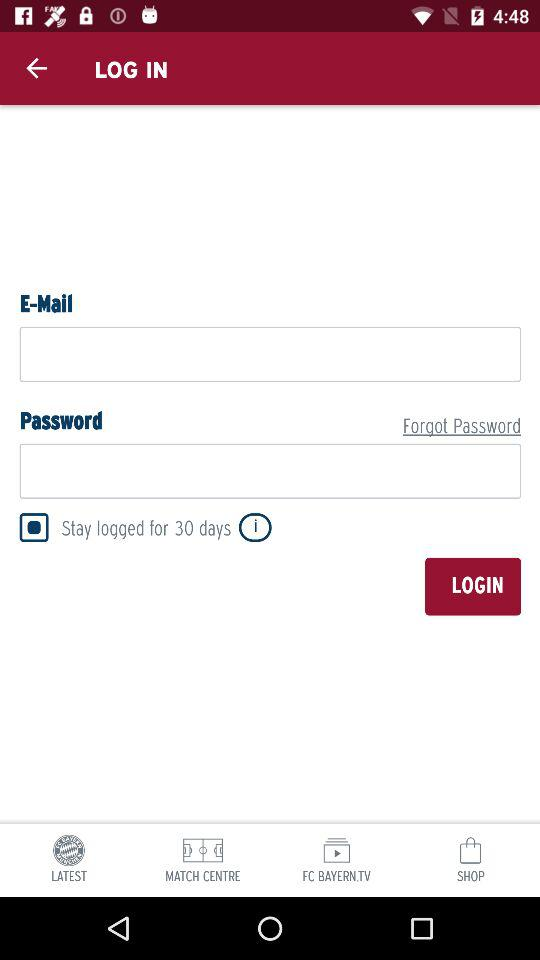What is the status of "Stay logged for 30 days"? The status is "on". 